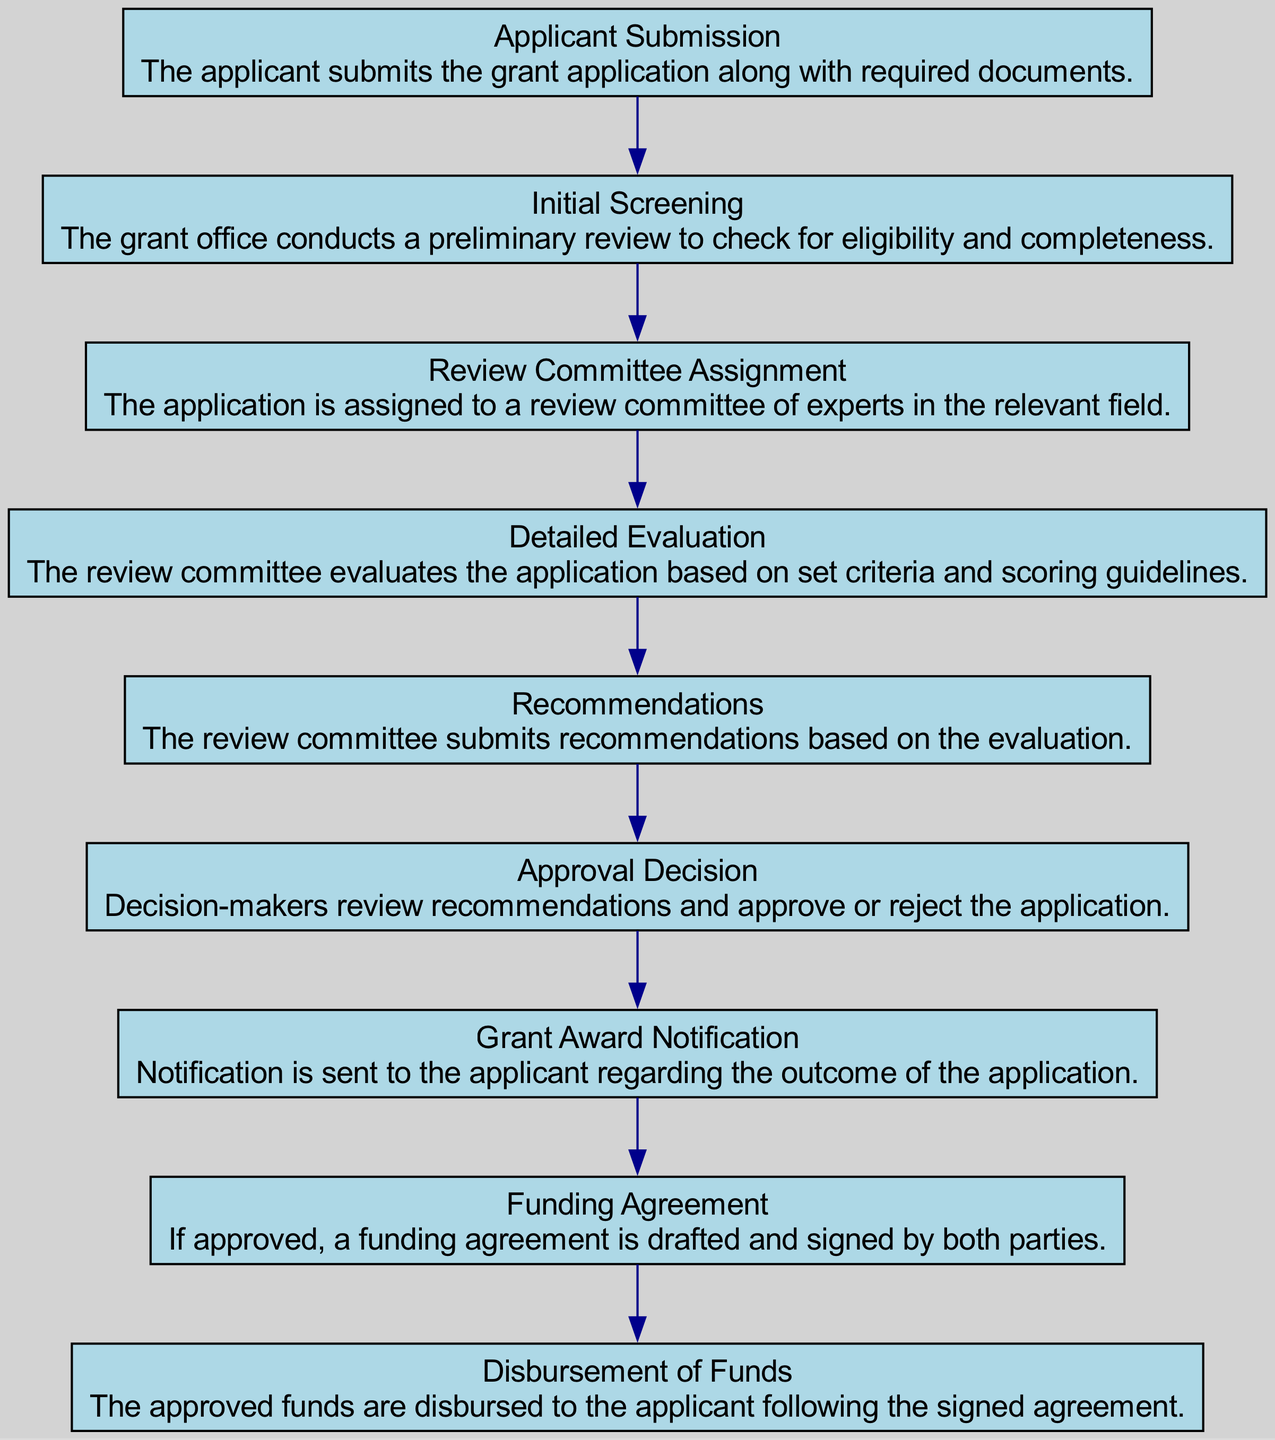What is the first step in the grant application process? The first step listed in the diagram is "Applicant Submission," indicating that the application process begins with the applicant submitting the grant application along with required documents.
Answer: Applicant Submission How many steps are there in total? By counting the number of sequence steps outlined in the diagram, including each distinct action from start to finish, we find there are nine total steps.
Answer: Nine Which step follows "Initial Screening"? In the sequence diagram, "Review Committee Assignment" comes immediately after "Initial Screening," meaning this is the next action taken once the initial screening is complete.
Answer: Review Committee Assignment At which stage are the recommendations made? The diagram indicates that recommendations are made during the "Recommendations" step, which follows the "Detailed Evaluation" step where evaluations occur.
Answer: Recommendations What is the last step in the grant application process? The last step is "Disbursement of Funds," as it represents the final action taken once the grant has been awarded and the funds have been transferred to the applicant.
Answer: Disbursement of Funds How many nodes are involved in the decision-making process of approval or rejection? The decision-making process involves reviewing recommendations and then either approving or rejecting the application, represented by the "Approval Decision" step, indicating a focus on a single node at this decision point.
Answer: One What happens after an application is approved? After an application is approved, the next step is the "Funding Agreement," where a formal agreement outlining the funding details is drafted and signed.
Answer: Funding Agreement Is the "Detailed Evaluation" step before or after "Grant Award Notification"? The "Detailed Evaluation" step occurs before "Grant Award Notification" since the evaluation must take place before any notification regarding the outcome can be provided.
Answer: Before Which two steps provide information directly to the applicant? The two steps that provide information directly to the applicant are "Grant Award Notification" and "Disbursement of Funds," as both involve communication and transactions between the grant office and the applicant.
Answer: Grant Award Notification, Disbursement of Funds 